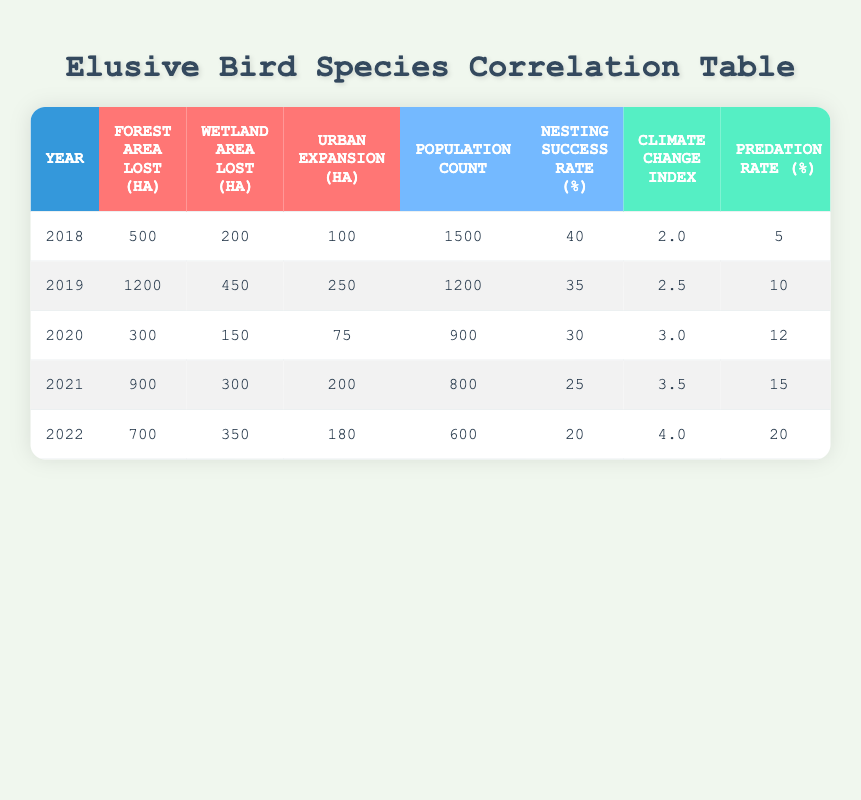What was the population count in 2019? In the table, under the "Population Count" column for the year 2019, the value is listed as 1200.
Answer: 1200 What is the correlation between urban expansion and population count from 2018 to 2022? To find this, we compare the "Urban Expansion" values and the "Population Count" values across those years: 2018 (100, 1500), 2019 (250, 1200), 2020 (75, 900), 2021 (200, 800), 2022 (180, 600). Calculating the correlation involves statistical methods but from visual inspection, as urban expansion increases, the population count generally decreases, indicating a negative correlation.
Answer: Negative correlation Was there a decrease in nesting success rate from 2018 to 2022? By checking the "Nesting Success Rate (%)" column, we see the values for those years: 2018 (40), 2019 (35), 2020 (30), 2021 (25), 2022 (20), which all show a declining trend over the years.
Answer: Yes Is the climate change index higher in 2022 than in 2018? Looking at the "Climate Change Index" column, the values are 2.0 for 2018 and 4.0 for 2022; since 4.0 is greater than 2.0, the statement is true.
Answer: Yes What is the average area lost in hectares (forest + wetland + urban) in 2021? For 2021, we sum the areas lost: Forest area lost (900) + Wetland area lost (300) + Urban expansion (200) = 1400 hectares. Then, we divide by the number of areas considered (3) to find the average: 1400 / 3 = approximately 466.67 hectares.
Answer: Approximately 466.67 hectares What is the population trend observed in 2020 concerning habitat loss? In 2020, the habitat losses were forest (300), wetland (150), and urban (75) with a population count of 900. Comparing this with previous years, there was a noticeable drop in the population count from 1200 in 2019, indicating a possible relationship between habitat loss and reduced population in that year.
Answer: Decrease in population trend Was the predation rate the same over the years 2018 to 2022? Checking the "Predation Rate (%)" column for those years: 5, 10, 12, 15, 20 shows that the values are increasing each year. Therefore, the rates were not the same.
Answer: No What was the total forest area lost from 2018 to 2022? We sum up the forest areas lost: 500 (2018) + 1200 (2019) + 300 (2020) + 900 (2021) + 700 (2022) = 3600 hectares.
Answer: 3600 hectares 